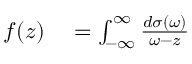<formula> <loc_0><loc_0><loc_500><loc_500>\begin{array} { r l } { f ( z ) } & = \int _ { - \infty } ^ { \infty } \frac { d \sigma ( \omega ) } { \omega - z } } \end{array}</formula> 